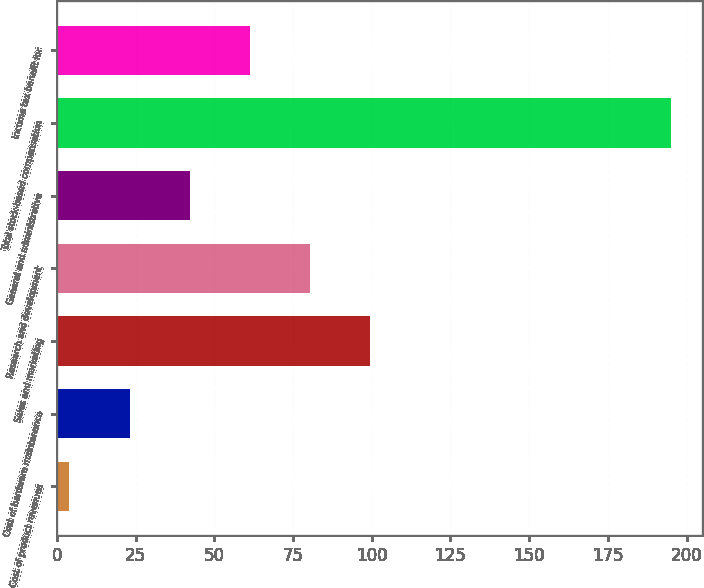Convert chart to OTSL. <chart><loc_0><loc_0><loc_500><loc_500><bar_chart><fcel>Cost of product revenues<fcel>Cost of hardware maintenance<fcel>Sales and marketing<fcel>Research and development<fcel>General and administrative<fcel>Total stock-based compensation<fcel>Income tax benefit for<nl><fcel>4<fcel>23.1<fcel>99.5<fcel>80.4<fcel>42.2<fcel>195<fcel>61.3<nl></chart> 